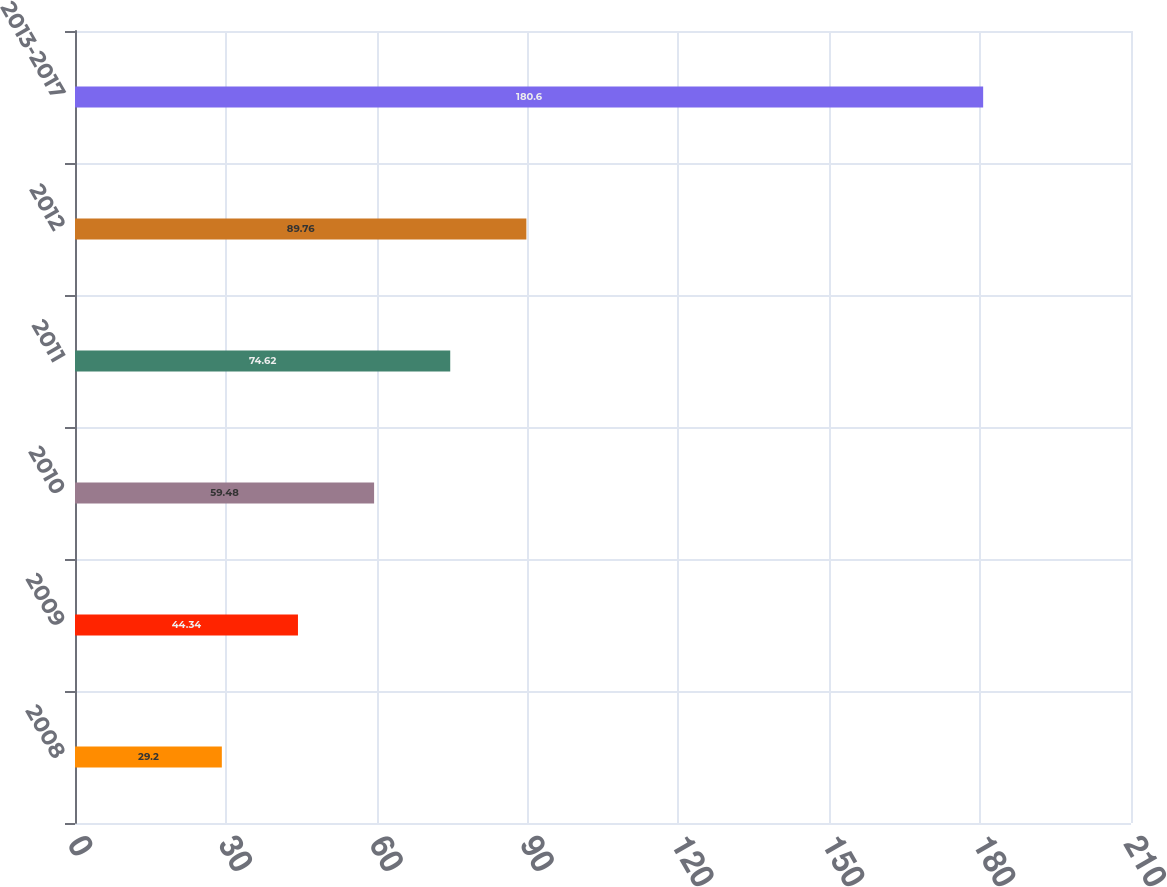Convert chart to OTSL. <chart><loc_0><loc_0><loc_500><loc_500><bar_chart><fcel>2008<fcel>2009<fcel>2010<fcel>2011<fcel>2012<fcel>2013-2017<nl><fcel>29.2<fcel>44.34<fcel>59.48<fcel>74.62<fcel>89.76<fcel>180.6<nl></chart> 